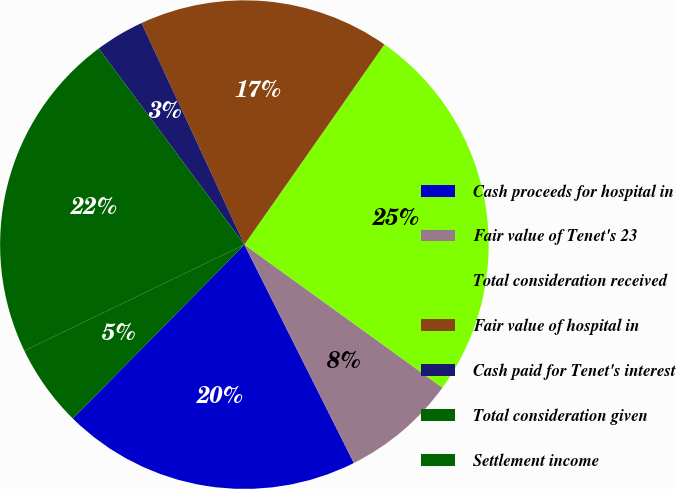<chart> <loc_0><loc_0><loc_500><loc_500><pie_chart><fcel>Cash proceeds for hospital in<fcel>Fair value of Tenet's 23<fcel>Total consideration received<fcel>Fair value of hospital in<fcel>Cash paid for Tenet's interest<fcel>Total consideration given<fcel>Settlement income<nl><fcel>19.79%<fcel>7.65%<fcel>25.24%<fcel>16.63%<fcel>3.25%<fcel>21.99%<fcel>5.45%<nl></chart> 